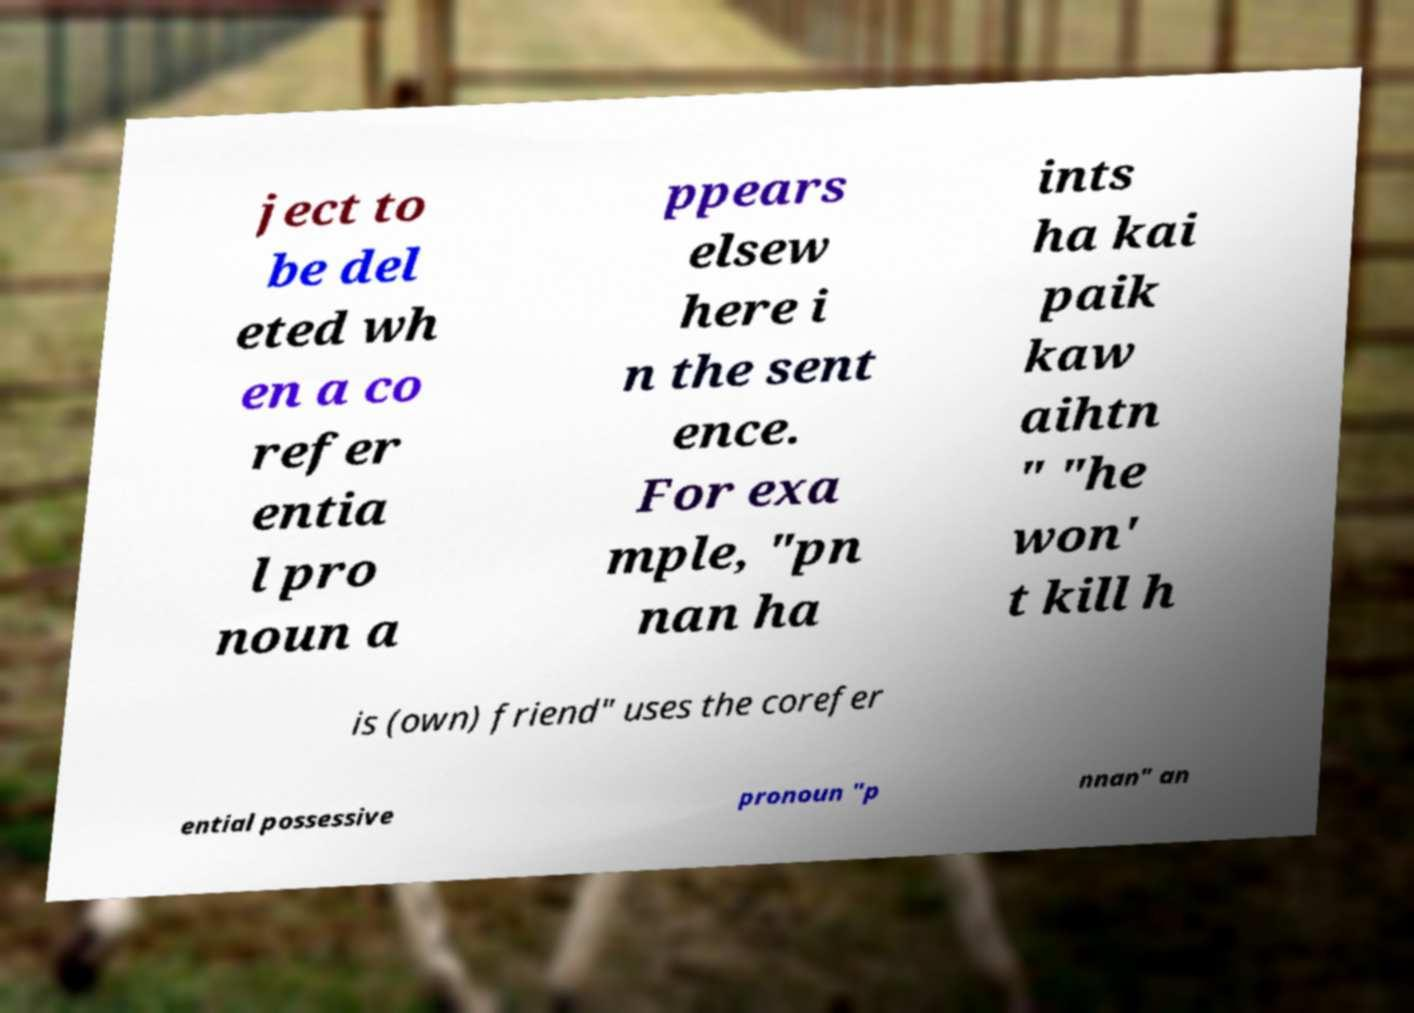Can you accurately transcribe the text from the provided image for me? ject to be del eted wh en a co refer entia l pro noun a ppears elsew here i n the sent ence. For exa mple, "pn nan ha ints ha kai paik kaw aihtn " "he won' t kill h is (own) friend" uses the corefer ential possessive pronoun "p nnan" an 